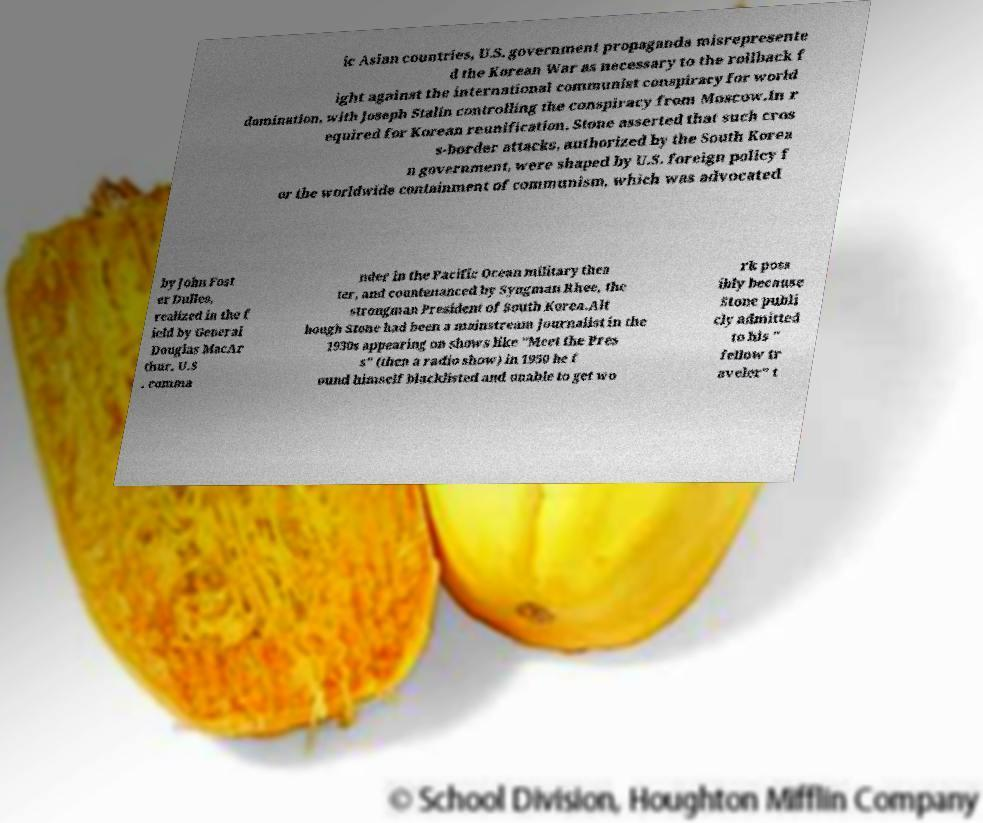Please read and relay the text visible in this image. What does it say? ic Asian countries, U.S. government propaganda misrepresente d the Korean War as necessary to the rollback f ight against the international communist conspiracy for world domination, with Joseph Stalin controlling the conspiracy from Moscow.In r equired for Korean reunification. Stone asserted that such cros s-border attacks, authorized by the South Korea n government, were shaped by U.S. foreign policy f or the worldwide containment of communism, which was advocated by John Fost er Dulles, realized in the f ield by General Douglas MacAr thur, U.S . comma nder in the Pacific Ocean military thea ter, and countenanced by Syngman Rhee, the strongman President of South Korea.Alt hough Stone had been a mainstream journalist in the 1930s appearing on shows like "Meet the Pres s" (then a radio show) in 1950 he f ound himself blacklisted and unable to get wo rk poss ibly because Stone publi cly admitted to his " fellow tr aveler" t 